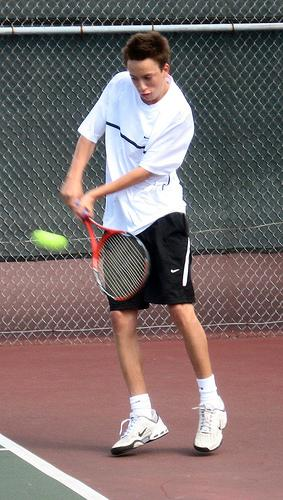Question: where was this photographed?
Choices:
A. Tennis court.
B. Football field.
C. Golf course.
D. Basketball court.
Answer with the letter. Answer: A Question: what is the man holding?
Choices:
A. A golf club.
B. A soccer ball.
C. A tennis racket.
D. A football.
Answer with the letter. Answer: C Question: what is the man attempting to hit?
Choices:
A. A baseball.
B. A volleyball.
C. A softball.
D. A tennis ball.
Answer with the letter. Answer: D Question: what color are the man's shorts?
Choices:
A. Black.
B. Red.
C. Blue.
D. White.
Answer with the letter. Answer: A Question: how many shoes is the man wearing?
Choices:
A. 1.
B. 0.
C. Two.
D. None.
Answer with the letter. Answer: C Question: what color is the majority of the man's shirt?
Choices:
A. Pink.
B. White.
C. Red.
D. Blue.
Answer with the letter. Answer: B 